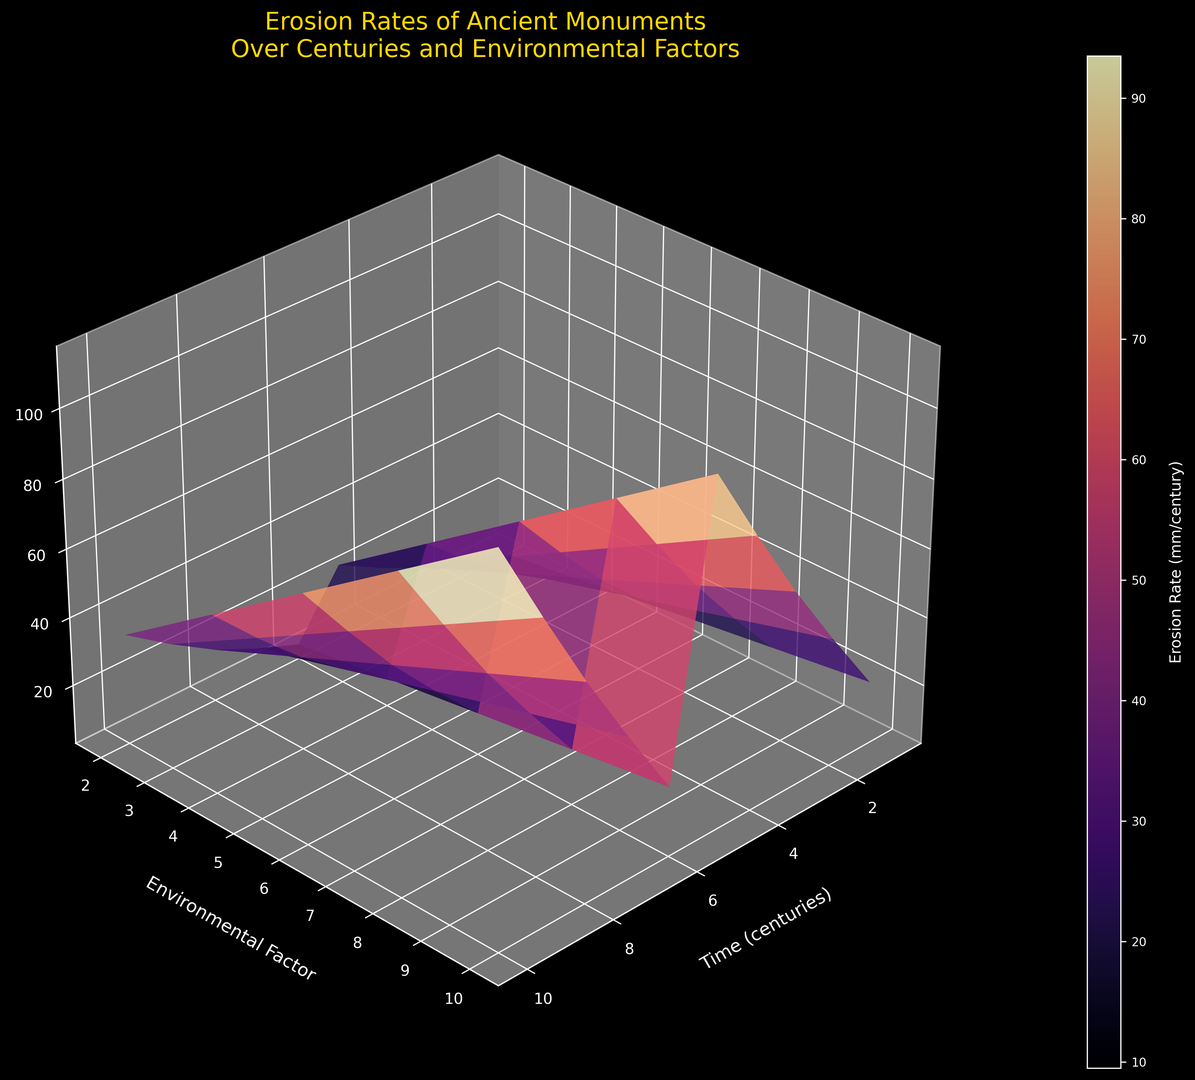What is the erosion rate after 5 centuries with an environmental factor of 10? Look at the point where the Time (centuries) is 5 and the Environmental Factor is 10 on the surface plot. Identify the corresponding erosion rate in the Z-axis.
Answer: 65 How does the erosion rate change between environmental factors 2 and 10 after 10 centuries? Check the erosion rates for Time (centuries) at 10 with Environmental Factors 2 and 10. Subtract the rate at factor 2 from the rate at factor 10.
Answer: 92 Which century shows the steepest increase in erosion rate for an environmental factor of 6? Observe the slope of the surface for Environmental Factor 6 over the Time axis and identify the century where the slope is steepest.
Answer: Century 10 What is the average erosion rate at centuries 4, 5, and 6 with an environmental factor of 4? Find the erosion rates at Time (centuries) 4, 5, and 6 with an Environmental Factor of 4. Calculate the average: (20 + 24 + 28)/3.
Answer: 24 At what combination of time and environmental factor is the erosion rate highest? Scan the entire surface plot and locate the point with the maximum height on the Z-axis.
Answer: 10 centuries and environmental factor of 10 Is the erosion rate at 8 centuries with an environmental factor of 8 higher than at 4 centuries with an environmental factor of 4? Compare the erosion rates for Time (centuries) of 8 at Environmental Factor 8 and Time (centuries) of 4 at Environmental Factor 4.
Answer: Yes By how much does the erosion rate increase from 2 centuries to 3 centuries for an environmental factor of 10? Compare the erosion rate at Time (centuries) 2 to Time (centuries) 3 for Environmental Factor 10. Subtract the former from the latter.
Answer: 10 What pattern do you notice in erosion rates as environmental factors increase from 2 to 10 over all centuries? Observe the trends in the Z-axis as Environmental Factor increases from 2 to 10 across all Time values. Comment on the overall change.
Answer: Increase What is the erosion rate with the smallest environmental factor at 9 centuries? Identify the erosion rate at Time (centuries) 9 for the smallest Environmental Factor, which is 2.
Answer: 21 